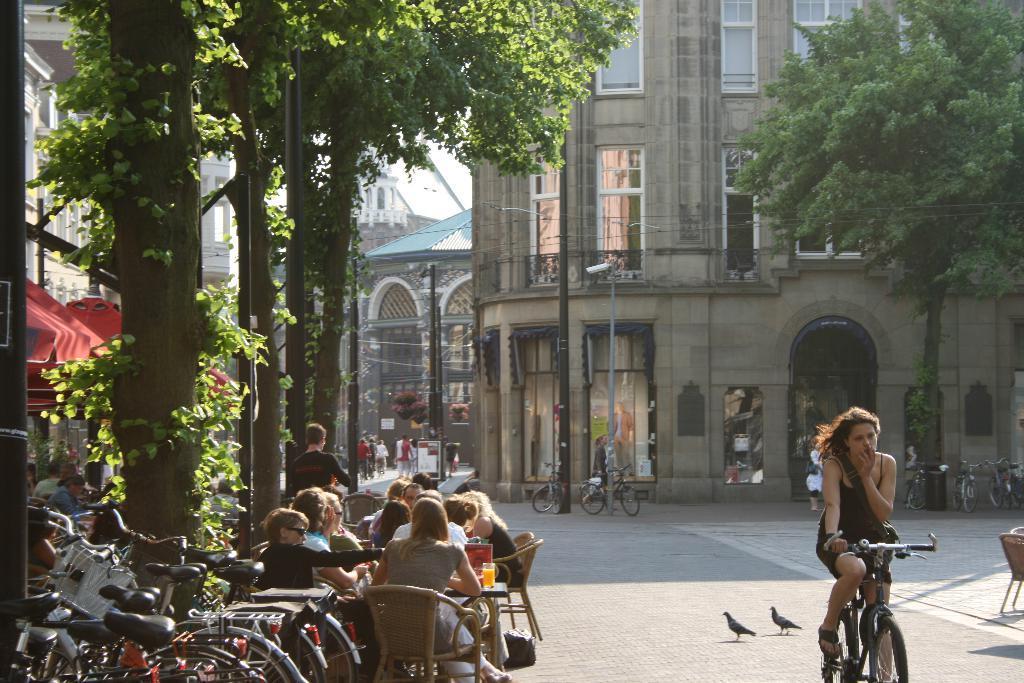How would you summarize this image in a sentence or two? The photo is taken on a road. On the left there are few cycle ,beside it few people are sitting on chair there are few tables present there. In the right a lady is riding a cycle. there are few trees in the left. In the background there is building, tree, few more cycles. There are two birds in the middle. 